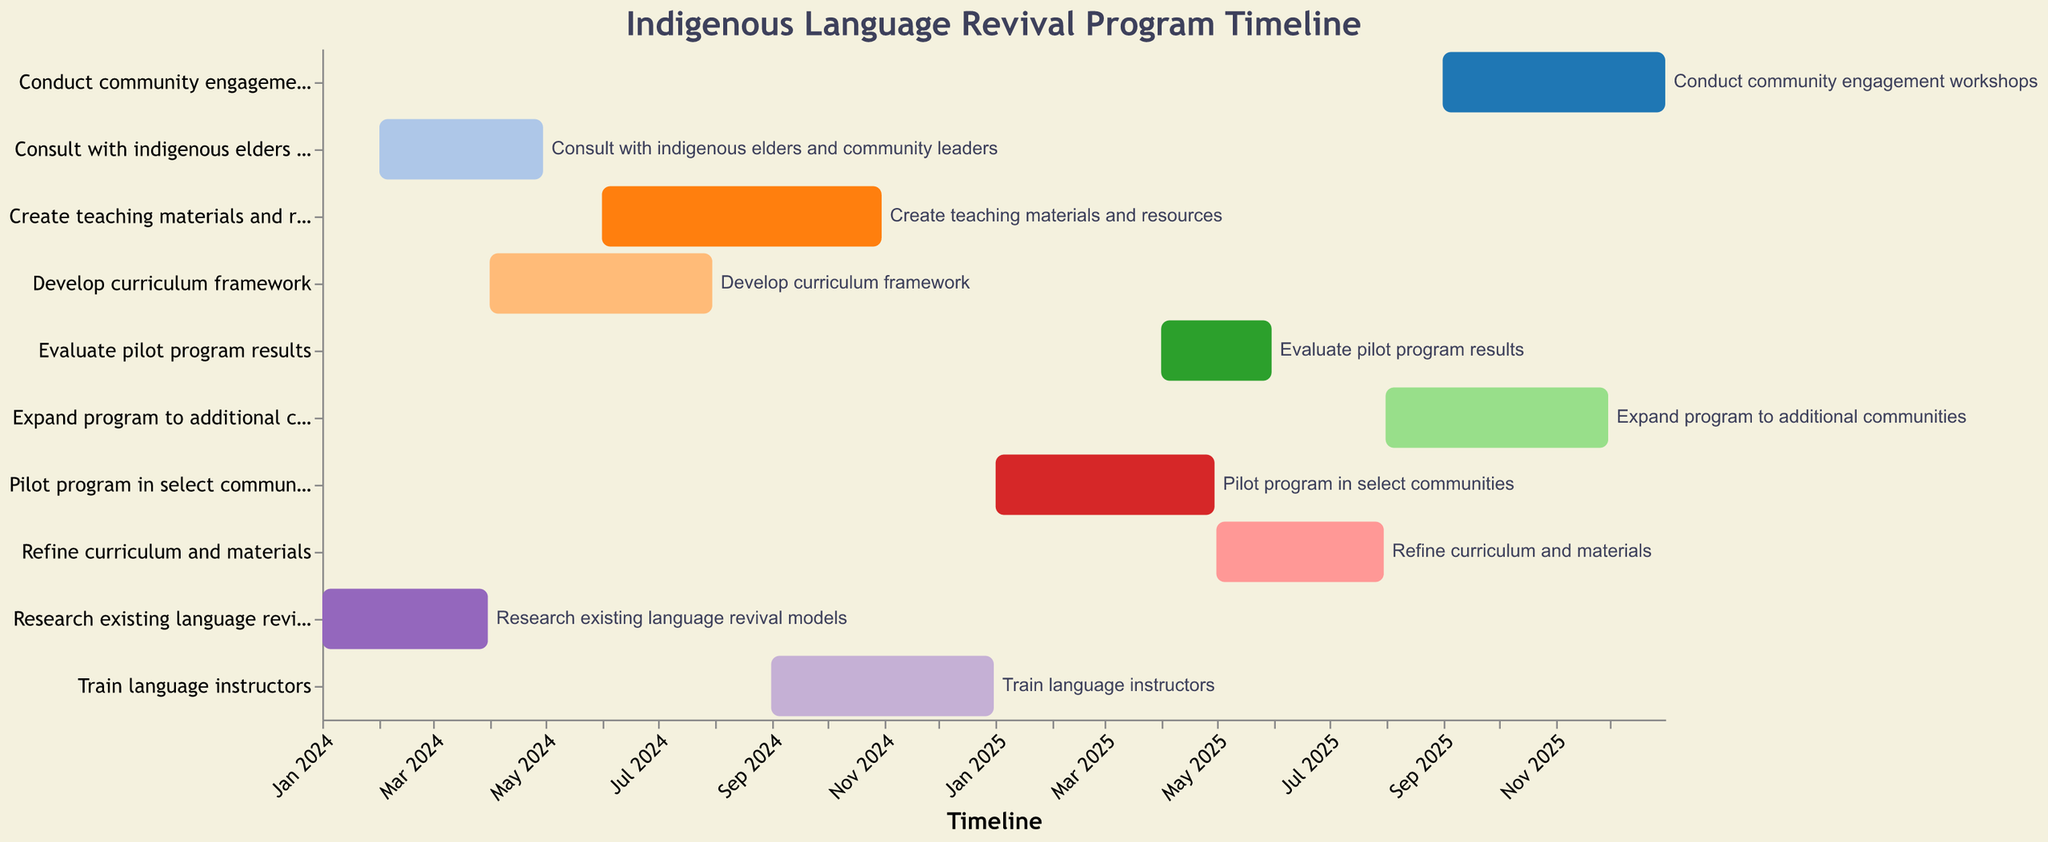What's the duration of the "Research existing language revival models" task? The task "Research existing language revival models" starts on 2024-01-01 and ends on 2024-03-31. The duration is the number of days between these dates. From January 1 to March 31 is 90 days.
Answer: 90 days Which task has the longest duration in the timeline? To determine the task with the longest duration, compare the start and end dates of each task. The "Create teaching materials and resources" task spans from 2024-06-01 to 2024-10-31, totaling 153 days, which is the longest.
Answer: Create teaching materials and resources When does the "Pilot program in select communities" start? The start date for the "Pilot program in select communities" is shown on the timeline. It begins on 2025-01-01.
Answer: 2025-01-01 How many tasks are scheduled to start in 2024? To find the number of tasks starting in 2024, count the tasks with a start date in 2024. There are five such tasks.
Answer: 5 Which tasks overlap with the "Develop curriculum framework"? "Develop curriculum framework" runs from 2024-04-01 to 2024-07-31. The overlapping tasks during this period are "Create teaching materials and resources," which starts on 2024-06-01.
Answer: Create teaching materials and resources What is the total duration from the start of the first task to the end of the last task? The program starts with "Research existing language revival models" on 2024-01-01 and ends with "Conduct community engagement workshops" on 2025-12-31. The total duration is from January 1, 2024, to December 31, 2025, which is 730 days.
Answer: 730 days Are there any tasks that both start and end within the same calendar year? Reviewing the tasks, those which start and end within the same calendar year include "Research existing language revival models" (2024), "Train language instructors" (2024), "Evaluate pilot program results" (2025), "Refine curriculum and materials" (2025), and "Expand program to additional communities" (2025).
Answer: Yes, there are five tasks Which task ends last in the timeline? The last end date on the timeline is for the "Conduct community engagement workshops" task, which ends on 2025-12-31.
Answer: Conduct community engagement workshops 